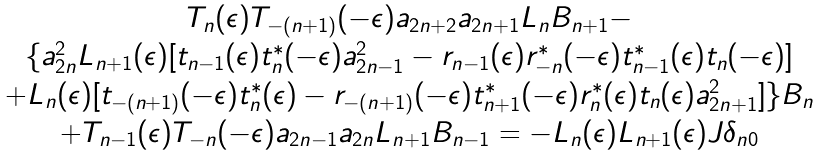Convert formula to latex. <formula><loc_0><loc_0><loc_500><loc_500>\begin{array} { c c } T _ { n } ( \epsilon ) T _ { - ( n + 1 ) } ( - \epsilon ) a _ { 2 n + 2 } a _ { 2 n + 1 } L _ { n } B _ { n + 1 } - \\ \{ a _ { 2 n } ^ { 2 } L _ { n + 1 } ( \epsilon ) [ t _ { n - 1 } ( \epsilon ) t _ { n } ^ { * } ( - \epsilon ) a ^ { 2 } _ { 2 n - 1 } - r _ { n - 1 } ( \epsilon ) r ^ { * } _ { - n } ( - \epsilon ) t _ { n - 1 } ^ { * } ( \epsilon ) t _ { n } ( - \epsilon ) ] \\ + L _ { n } ( \epsilon ) [ t _ { - ( n + 1 ) } ( - \epsilon ) t _ { n } ^ { * } ( \epsilon ) - r _ { - ( n + 1 ) } ( - \epsilon ) t _ { n + 1 } ^ { * } ( - \epsilon ) r _ { n } ^ { * } ( \epsilon ) t _ { n } ( \epsilon ) a _ { 2 n + 1 } ^ { 2 } ] \} B _ { n } \\ + T _ { n - 1 } ( \epsilon ) T _ { - n } ( - \epsilon ) a _ { 2 n - 1 } a _ { 2 n } L _ { n + 1 } B _ { n - 1 } = - L _ { n } ( \epsilon ) L _ { n + 1 } ( \epsilon ) J \delta _ { n 0 } \end{array}</formula> 